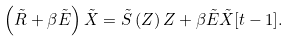Convert formula to latex. <formula><loc_0><loc_0><loc_500><loc_500>\left ( \tilde { R } + \beta \tilde { E } \right ) \tilde { X } = \tilde { S } \left ( Z \right ) Z + \beta \tilde { E } \tilde { X } [ t - 1 ] .</formula> 